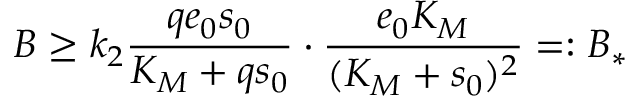Convert formula to latex. <formula><loc_0><loc_0><loc_500><loc_500>B \geq k _ { 2 } \frac { q e _ { 0 } s _ { 0 } } { K _ { M } + q s _ { 0 } } \cdot \frac { e _ { 0 } K _ { M } } { ( K _ { M } + s _ { 0 } ) ^ { 2 } } = \colon B _ { * }</formula> 